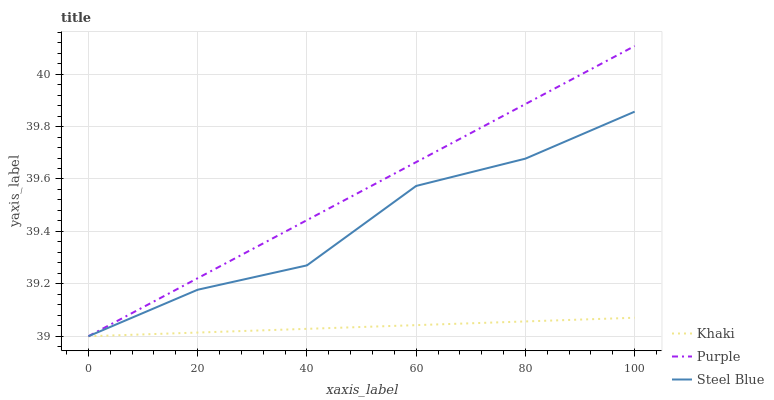Does Steel Blue have the minimum area under the curve?
Answer yes or no. No. Does Steel Blue have the maximum area under the curve?
Answer yes or no. No. Is Steel Blue the smoothest?
Answer yes or no. No. Is Khaki the roughest?
Answer yes or no. No. Does Steel Blue have the highest value?
Answer yes or no. No. 